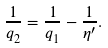Convert formula to latex. <formula><loc_0><loc_0><loc_500><loc_500>\frac { 1 } { q _ { 2 } } = \frac { 1 } { q _ { 1 } } - \frac { 1 } { \eta ^ { \prime } } . \text { }</formula> 